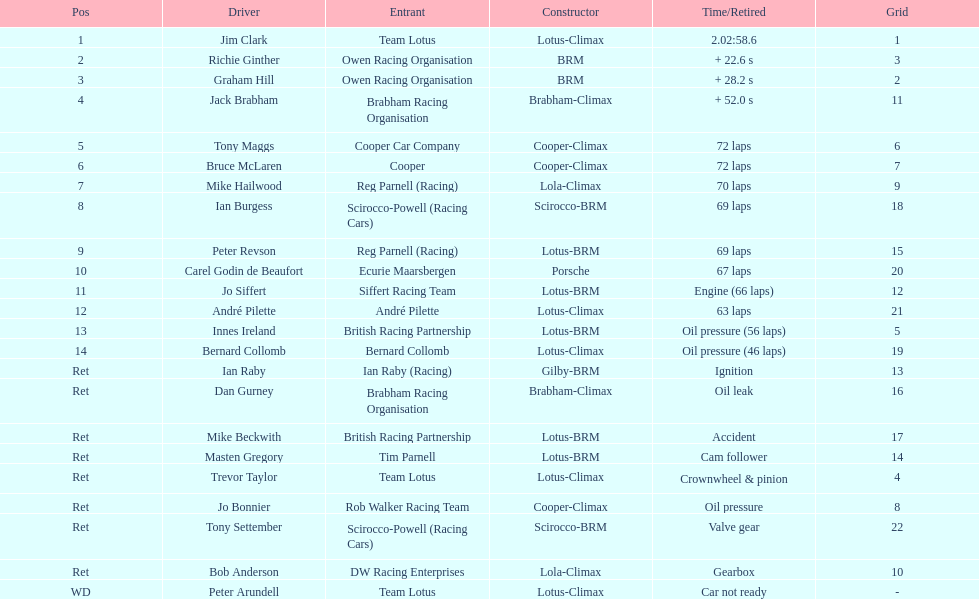What country had the least number of drivers, germany or the uk? Germany. 